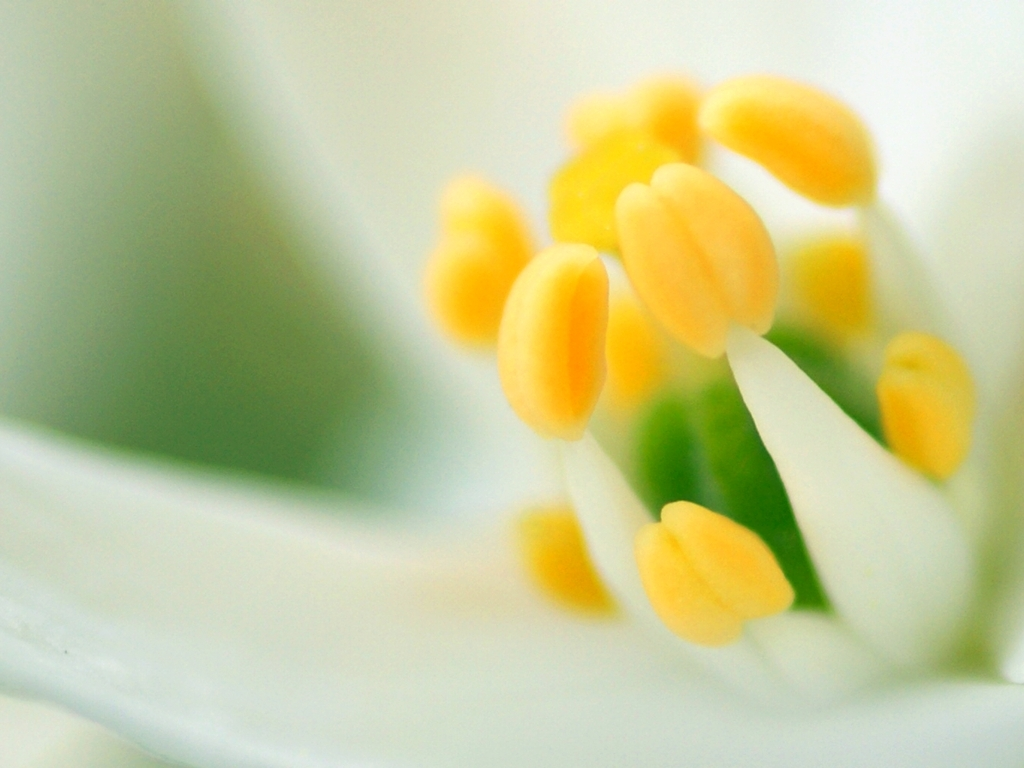Are there any quality issues with this image? The image appears to be slightly overexposed, resulting in a loss of detail on the white petals which look washed out. Additionally, there seems to be a narrow depth of field, making only a small portion of the image, particularly the yellow anthers, in sharp focus while the rest is blurred. This effect could be intentional to artistically highlight these parts, but it does limit the overall sharpness of the image. 